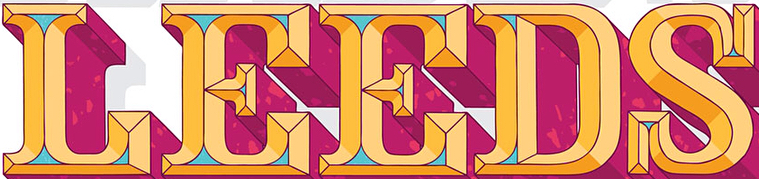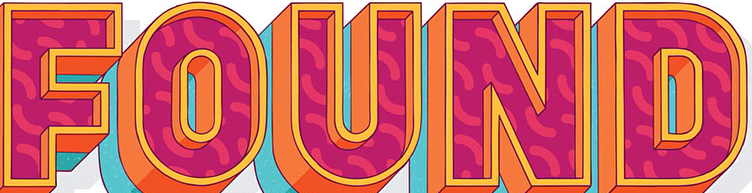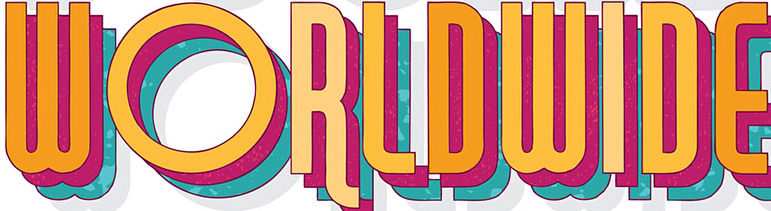Identify the words shown in these images in order, separated by a semicolon. LEEDS; FOUND; WORLDWIDE 